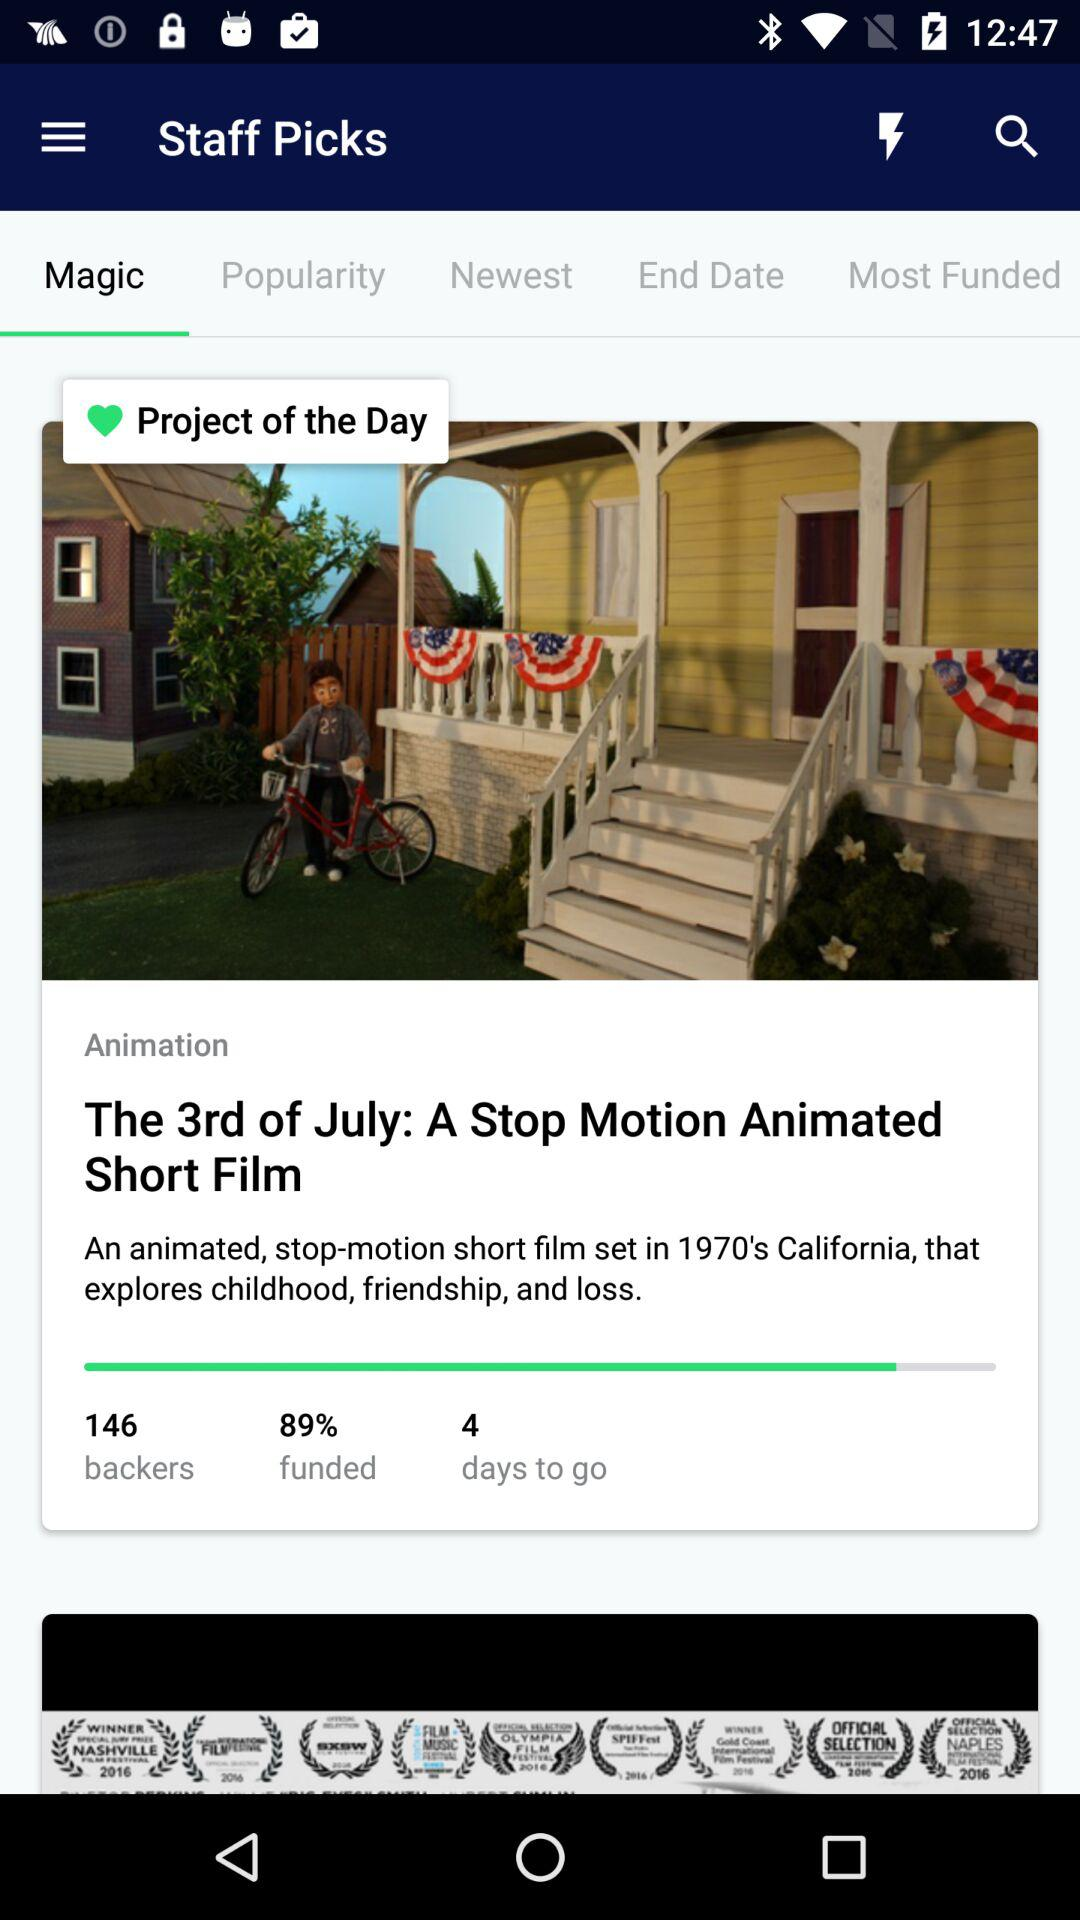How many backers are there? There are 146 backers. 